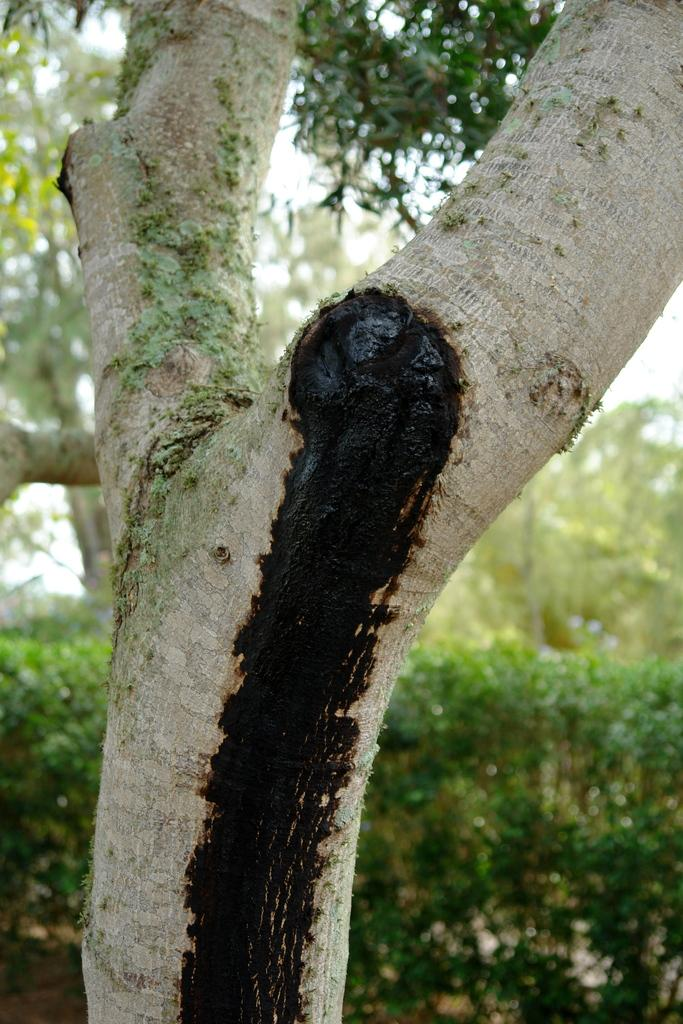What type of vegetation can be seen in the image? There are trees and plants in the image. Can you describe any specific features of the trees? There is a black mark on a tree in the foreground. What is visible at the top of the image? The sky is visible at the top of the image. What is visible at the bottom of the image? The ground is visible at the bottom of the image. What type of rail can be seen connecting the trees in the image? There is no rail present in the image; it features trees and plants without any connecting structures. Can you tell me how many pickles are hanging from the branches of the trees? There are no pickles present in the image; it features trees and plants without any fruits or vegetables. 